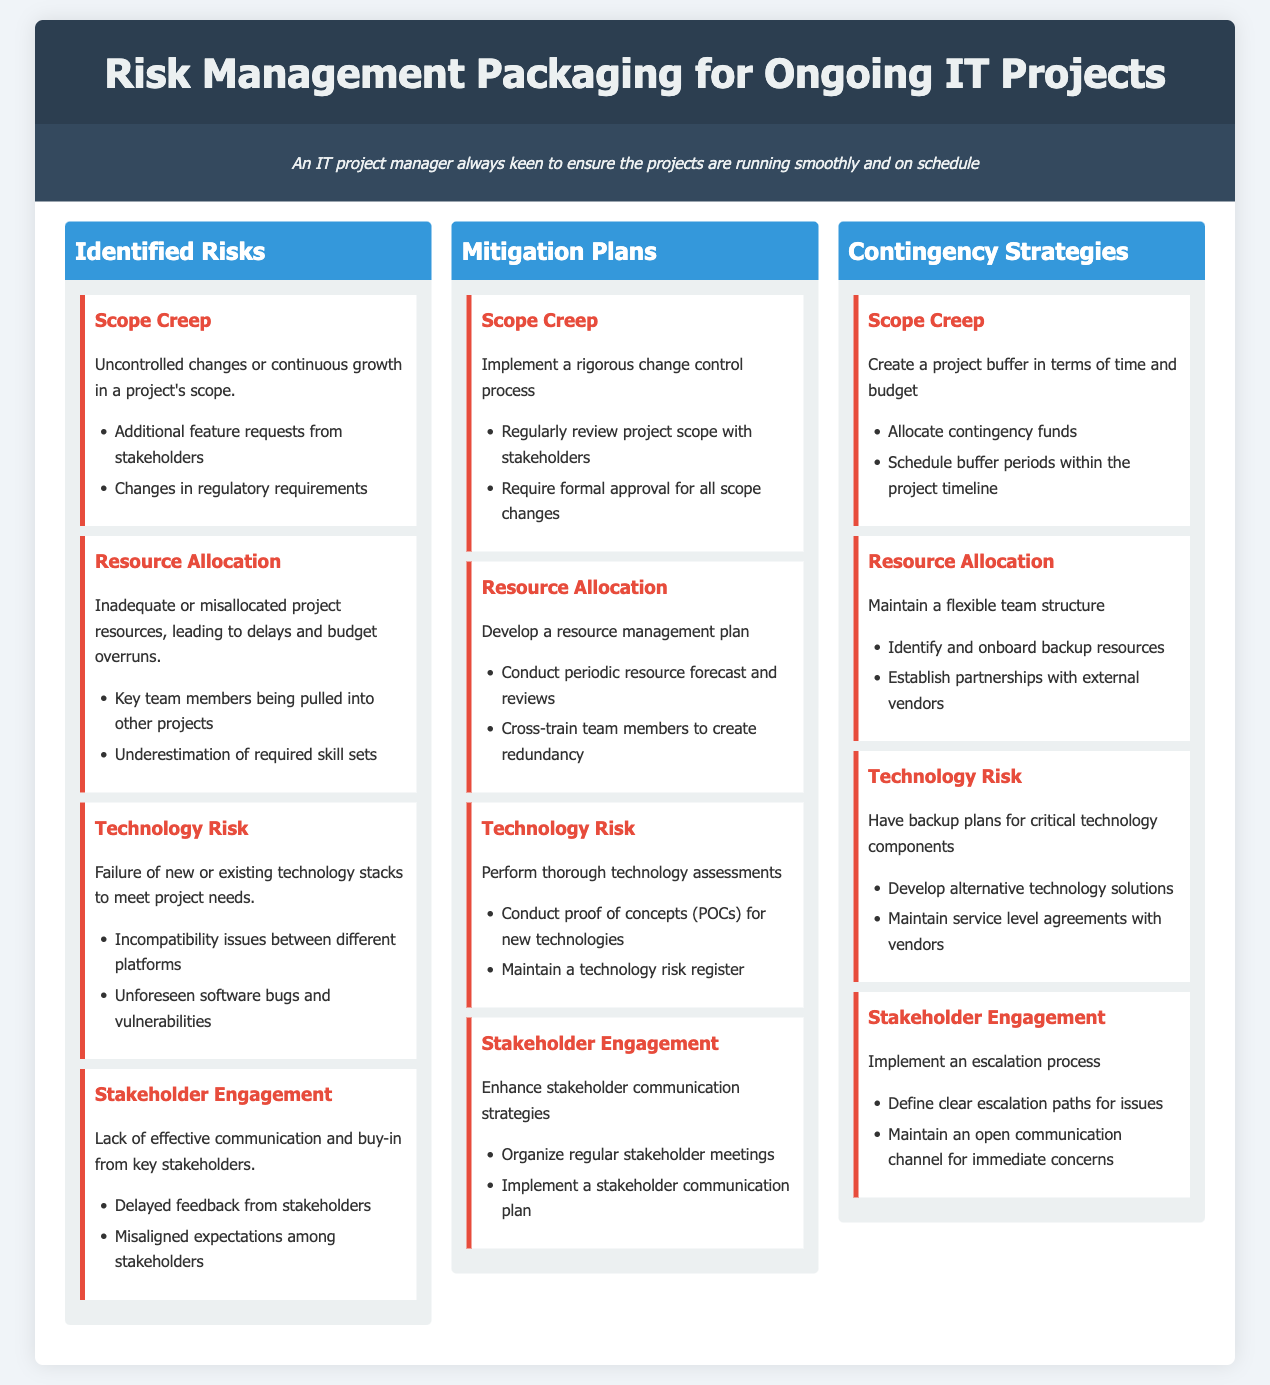What is the title of the document? The title of the document is clearly stated in the header section.
Answer: Risk Management Packaging for Ongoing IT Projects How many identified risks are listed? The document contains a section on identified risks that includes several distinct items.
Answer: 4 What is the mitigation plan for Scope Creep? The section on mitigation plans provides specific strategies for managing Scope Creep.
Answer: Implement a rigorous change control process What contingency strategy is suggested for Resource Allocation? The contingency strategies section outlines specific plans for Resource Allocation.
Answer: Maintain a flexible team structure What type of risk is associated with new technologies? The document categorizes risks and assigns them distinct types.
Answer: Technology Risk What is a potential cause of Stakeholder Engagement issues? The identified risks provide reasons for difficulties faced in stakeholder engagement.
Answer: Delayed feedback from stakeholders How many items are listed under Technology Risk's mitigation plan? The mitigation section's specific plans under Technology Risk can be counted.
Answer: 2 What should be developed for critical technology components? The contingency strategies for Technology Risk specify what needs to be in place.
Answer: Backup plans 